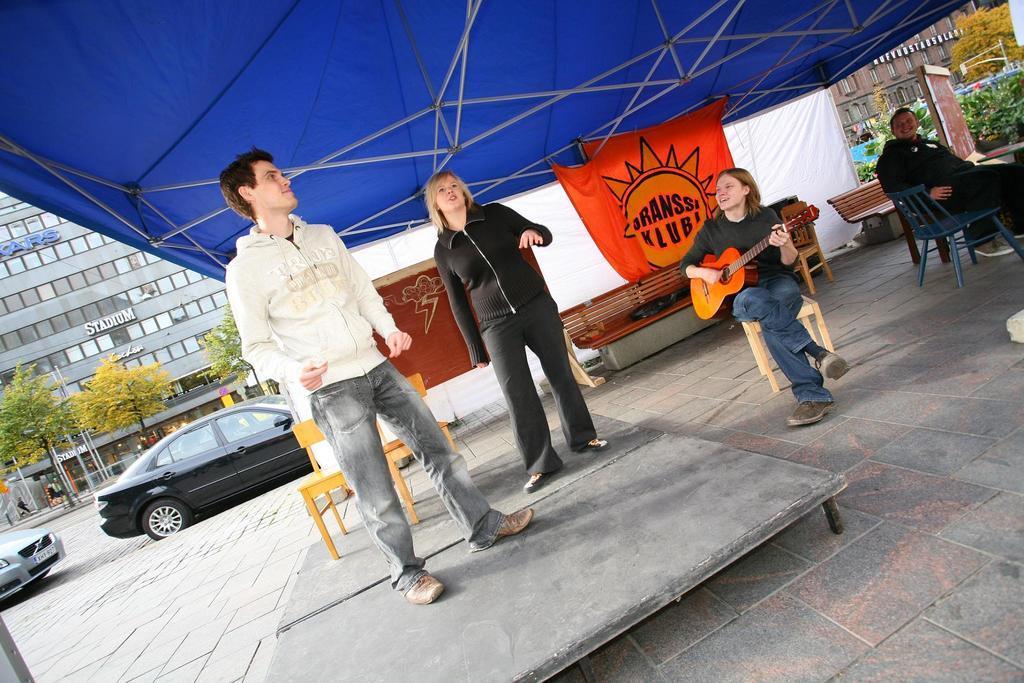In one or two sentences, can you explain what this image depicts? As we can see in the image there is a building, trees, two cars on road and there are few people over here and the woman who is sitting here is holding guitar. 